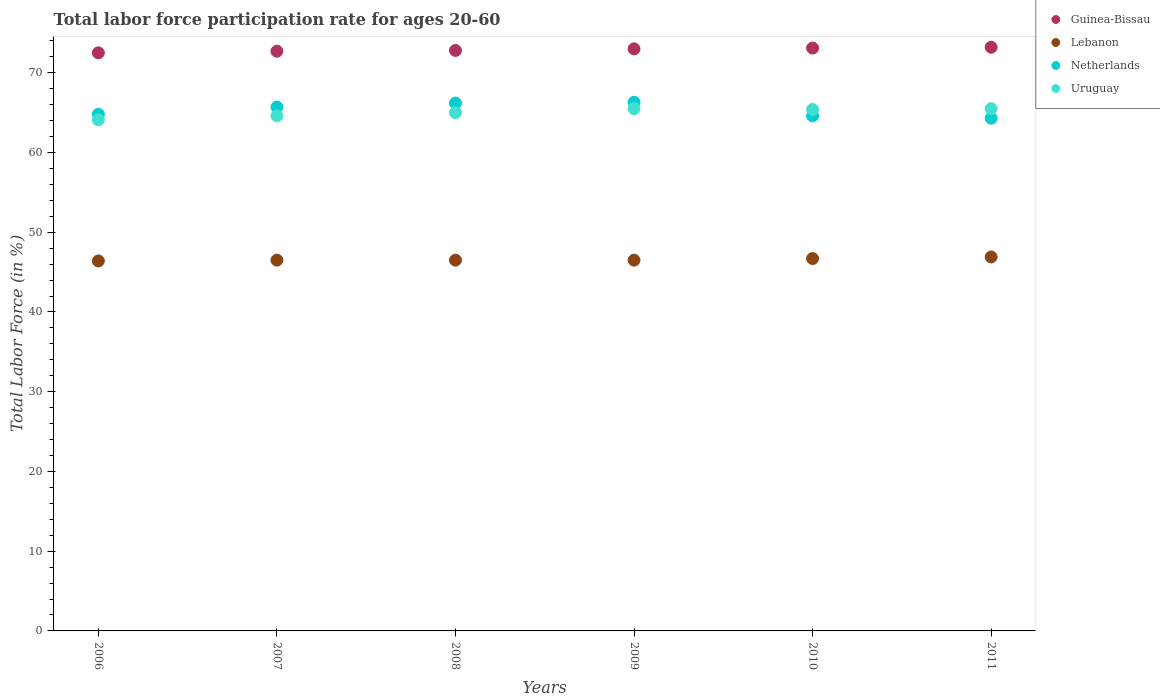How many different coloured dotlines are there?
Offer a terse response. 4. Is the number of dotlines equal to the number of legend labels?
Your answer should be very brief. Yes. What is the labor force participation rate in Lebanon in 2008?
Provide a short and direct response. 46.5. Across all years, what is the maximum labor force participation rate in Lebanon?
Keep it short and to the point. 46.9. Across all years, what is the minimum labor force participation rate in Lebanon?
Give a very brief answer. 46.4. What is the total labor force participation rate in Guinea-Bissau in the graph?
Provide a short and direct response. 437.3. What is the difference between the labor force participation rate in Netherlands in 2007 and that in 2010?
Your answer should be compact. 1.1. What is the difference between the labor force participation rate in Uruguay in 2006 and the labor force participation rate in Lebanon in 2007?
Make the answer very short. 17.6. What is the average labor force participation rate in Uruguay per year?
Your answer should be very brief. 65.02. In the year 2007, what is the difference between the labor force participation rate in Netherlands and labor force participation rate in Uruguay?
Give a very brief answer. 1.1. What is the ratio of the labor force participation rate in Lebanon in 2006 to that in 2007?
Give a very brief answer. 1. What is the difference between the highest and the second highest labor force participation rate in Netherlands?
Keep it short and to the point. 0.1. In how many years, is the labor force participation rate in Guinea-Bissau greater than the average labor force participation rate in Guinea-Bissau taken over all years?
Give a very brief answer. 3. Is the sum of the labor force participation rate in Guinea-Bissau in 2008 and 2010 greater than the maximum labor force participation rate in Lebanon across all years?
Provide a short and direct response. Yes. Is it the case that in every year, the sum of the labor force participation rate in Guinea-Bissau and labor force participation rate in Netherlands  is greater than the sum of labor force participation rate in Lebanon and labor force participation rate in Uruguay?
Keep it short and to the point. Yes. Does the labor force participation rate in Uruguay monotonically increase over the years?
Your response must be concise. No. Is the labor force participation rate in Lebanon strictly greater than the labor force participation rate in Netherlands over the years?
Your answer should be compact. No. How many dotlines are there?
Your answer should be very brief. 4. How many years are there in the graph?
Provide a short and direct response. 6. What is the difference between two consecutive major ticks on the Y-axis?
Offer a terse response. 10. Are the values on the major ticks of Y-axis written in scientific E-notation?
Your answer should be very brief. No. Does the graph contain any zero values?
Give a very brief answer. No. Does the graph contain grids?
Your answer should be compact. No. How many legend labels are there?
Keep it short and to the point. 4. What is the title of the graph?
Your answer should be compact. Total labor force participation rate for ages 20-60. What is the label or title of the Y-axis?
Your answer should be very brief. Total Labor Force (in %). What is the Total Labor Force (in %) of Guinea-Bissau in 2006?
Make the answer very short. 72.5. What is the Total Labor Force (in %) of Lebanon in 2006?
Make the answer very short. 46.4. What is the Total Labor Force (in %) in Netherlands in 2006?
Your response must be concise. 64.8. What is the Total Labor Force (in %) in Uruguay in 2006?
Offer a terse response. 64.1. What is the Total Labor Force (in %) in Guinea-Bissau in 2007?
Your answer should be compact. 72.7. What is the Total Labor Force (in %) in Lebanon in 2007?
Your response must be concise. 46.5. What is the Total Labor Force (in %) of Netherlands in 2007?
Provide a short and direct response. 65.7. What is the Total Labor Force (in %) in Uruguay in 2007?
Make the answer very short. 64.6. What is the Total Labor Force (in %) of Guinea-Bissau in 2008?
Provide a short and direct response. 72.8. What is the Total Labor Force (in %) of Lebanon in 2008?
Ensure brevity in your answer.  46.5. What is the Total Labor Force (in %) in Netherlands in 2008?
Your answer should be compact. 66.2. What is the Total Labor Force (in %) of Uruguay in 2008?
Provide a succinct answer. 65. What is the Total Labor Force (in %) in Guinea-Bissau in 2009?
Your response must be concise. 73. What is the Total Labor Force (in %) of Lebanon in 2009?
Provide a short and direct response. 46.5. What is the Total Labor Force (in %) in Netherlands in 2009?
Give a very brief answer. 66.3. What is the Total Labor Force (in %) of Uruguay in 2009?
Make the answer very short. 65.5. What is the Total Labor Force (in %) in Guinea-Bissau in 2010?
Your response must be concise. 73.1. What is the Total Labor Force (in %) in Lebanon in 2010?
Ensure brevity in your answer.  46.7. What is the Total Labor Force (in %) of Netherlands in 2010?
Your answer should be compact. 64.6. What is the Total Labor Force (in %) in Uruguay in 2010?
Ensure brevity in your answer.  65.4. What is the Total Labor Force (in %) in Guinea-Bissau in 2011?
Give a very brief answer. 73.2. What is the Total Labor Force (in %) of Lebanon in 2011?
Give a very brief answer. 46.9. What is the Total Labor Force (in %) of Netherlands in 2011?
Your response must be concise. 64.3. What is the Total Labor Force (in %) of Uruguay in 2011?
Offer a very short reply. 65.5. Across all years, what is the maximum Total Labor Force (in %) in Guinea-Bissau?
Provide a short and direct response. 73.2. Across all years, what is the maximum Total Labor Force (in %) in Lebanon?
Ensure brevity in your answer.  46.9. Across all years, what is the maximum Total Labor Force (in %) of Netherlands?
Offer a terse response. 66.3. Across all years, what is the maximum Total Labor Force (in %) of Uruguay?
Provide a short and direct response. 65.5. Across all years, what is the minimum Total Labor Force (in %) in Guinea-Bissau?
Provide a succinct answer. 72.5. Across all years, what is the minimum Total Labor Force (in %) in Lebanon?
Your response must be concise. 46.4. Across all years, what is the minimum Total Labor Force (in %) in Netherlands?
Offer a terse response. 64.3. Across all years, what is the minimum Total Labor Force (in %) in Uruguay?
Provide a short and direct response. 64.1. What is the total Total Labor Force (in %) of Guinea-Bissau in the graph?
Offer a terse response. 437.3. What is the total Total Labor Force (in %) of Lebanon in the graph?
Give a very brief answer. 279.5. What is the total Total Labor Force (in %) in Netherlands in the graph?
Keep it short and to the point. 391.9. What is the total Total Labor Force (in %) of Uruguay in the graph?
Offer a very short reply. 390.1. What is the difference between the Total Labor Force (in %) in Guinea-Bissau in 2006 and that in 2007?
Offer a very short reply. -0.2. What is the difference between the Total Labor Force (in %) in Guinea-Bissau in 2006 and that in 2008?
Make the answer very short. -0.3. What is the difference between the Total Labor Force (in %) of Netherlands in 2006 and that in 2008?
Make the answer very short. -1.4. What is the difference between the Total Labor Force (in %) of Netherlands in 2006 and that in 2009?
Make the answer very short. -1.5. What is the difference between the Total Labor Force (in %) of Guinea-Bissau in 2006 and that in 2010?
Offer a terse response. -0.6. What is the difference between the Total Labor Force (in %) in Netherlands in 2006 and that in 2010?
Make the answer very short. 0.2. What is the difference between the Total Labor Force (in %) in Uruguay in 2006 and that in 2010?
Your answer should be compact. -1.3. What is the difference between the Total Labor Force (in %) of Guinea-Bissau in 2006 and that in 2011?
Make the answer very short. -0.7. What is the difference between the Total Labor Force (in %) in Guinea-Bissau in 2007 and that in 2008?
Your response must be concise. -0.1. What is the difference between the Total Labor Force (in %) in Netherlands in 2007 and that in 2008?
Give a very brief answer. -0.5. What is the difference between the Total Labor Force (in %) in Uruguay in 2007 and that in 2008?
Your answer should be very brief. -0.4. What is the difference between the Total Labor Force (in %) in Guinea-Bissau in 2007 and that in 2009?
Offer a very short reply. -0.3. What is the difference between the Total Labor Force (in %) of Netherlands in 2007 and that in 2009?
Offer a terse response. -0.6. What is the difference between the Total Labor Force (in %) of Uruguay in 2007 and that in 2009?
Provide a short and direct response. -0.9. What is the difference between the Total Labor Force (in %) of Guinea-Bissau in 2007 and that in 2010?
Give a very brief answer. -0.4. What is the difference between the Total Labor Force (in %) of Uruguay in 2007 and that in 2010?
Give a very brief answer. -0.8. What is the difference between the Total Labor Force (in %) of Guinea-Bissau in 2007 and that in 2011?
Offer a very short reply. -0.5. What is the difference between the Total Labor Force (in %) of Lebanon in 2007 and that in 2011?
Provide a succinct answer. -0.4. What is the difference between the Total Labor Force (in %) of Netherlands in 2007 and that in 2011?
Give a very brief answer. 1.4. What is the difference between the Total Labor Force (in %) in Lebanon in 2008 and that in 2009?
Your answer should be very brief. 0. What is the difference between the Total Labor Force (in %) in Guinea-Bissau in 2008 and that in 2010?
Keep it short and to the point. -0.3. What is the difference between the Total Labor Force (in %) of Uruguay in 2008 and that in 2010?
Offer a very short reply. -0.4. What is the difference between the Total Labor Force (in %) in Lebanon in 2008 and that in 2011?
Keep it short and to the point. -0.4. What is the difference between the Total Labor Force (in %) of Netherlands in 2008 and that in 2011?
Offer a terse response. 1.9. What is the difference between the Total Labor Force (in %) of Guinea-Bissau in 2009 and that in 2010?
Give a very brief answer. -0.1. What is the difference between the Total Labor Force (in %) of Netherlands in 2009 and that in 2010?
Ensure brevity in your answer.  1.7. What is the difference between the Total Labor Force (in %) of Guinea-Bissau in 2010 and that in 2011?
Your answer should be compact. -0.1. What is the difference between the Total Labor Force (in %) of Lebanon in 2010 and that in 2011?
Your response must be concise. -0.2. What is the difference between the Total Labor Force (in %) of Guinea-Bissau in 2006 and the Total Labor Force (in %) of Lebanon in 2007?
Your answer should be compact. 26. What is the difference between the Total Labor Force (in %) of Guinea-Bissau in 2006 and the Total Labor Force (in %) of Uruguay in 2007?
Give a very brief answer. 7.9. What is the difference between the Total Labor Force (in %) in Lebanon in 2006 and the Total Labor Force (in %) in Netherlands in 2007?
Ensure brevity in your answer.  -19.3. What is the difference between the Total Labor Force (in %) in Lebanon in 2006 and the Total Labor Force (in %) in Uruguay in 2007?
Your response must be concise. -18.2. What is the difference between the Total Labor Force (in %) of Lebanon in 2006 and the Total Labor Force (in %) of Netherlands in 2008?
Your answer should be compact. -19.8. What is the difference between the Total Labor Force (in %) of Lebanon in 2006 and the Total Labor Force (in %) of Uruguay in 2008?
Your response must be concise. -18.6. What is the difference between the Total Labor Force (in %) in Netherlands in 2006 and the Total Labor Force (in %) in Uruguay in 2008?
Your answer should be compact. -0.2. What is the difference between the Total Labor Force (in %) of Guinea-Bissau in 2006 and the Total Labor Force (in %) of Netherlands in 2009?
Keep it short and to the point. 6.2. What is the difference between the Total Labor Force (in %) of Lebanon in 2006 and the Total Labor Force (in %) of Netherlands in 2009?
Your response must be concise. -19.9. What is the difference between the Total Labor Force (in %) in Lebanon in 2006 and the Total Labor Force (in %) in Uruguay in 2009?
Ensure brevity in your answer.  -19.1. What is the difference between the Total Labor Force (in %) of Netherlands in 2006 and the Total Labor Force (in %) of Uruguay in 2009?
Provide a succinct answer. -0.7. What is the difference between the Total Labor Force (in %) in Guinea-Bissau in 2006 and the Total Labor Force (in %) in Lebanon in 2010?
Give a very brief answer. 25.8. What is the difference between the Total Labor Force (in %) of Guinea-Bissau in 2006 and the Total Labor Force (in %) of Uruguay in 2010?
Ensure brevity in your answer.  7.1. What is the difference between the Total Labor Force (in %) of Lebanon in 2006 and the Total Labor Force (in %) of Netherlands in 2010?
Ensure brevity in your answer.  -18.2. What is the difference between the Total Labor Force (in %) of Lebanon in 2006 and the Total Labor Force (in %) of Uruguay in 2010?
Make the answer very short. -19. What is the difference between the Total Labor Force (in %) of Netherlands in 2006 and the Total Labor Force (in %) of Uruguay in 2010?
Your answer should be compact. -0.6. What is the difference between the Total Labor Force (in %) in Guinea-Bissau in 2006 and the Total Labor Force (in %) in Lebanon in 2011?
Provide a succinct answer. 25.6. What is the difference between the Total Labor Force (in %) of Guinea-Bissau in 2006 and the Total Labor Force (in %) of Netherlands in 2011?
Give a very brief answer. 8.2. What is the difference between the Total Labor Force (in %) of Guinea-Bissau in 2006 and the Total Labor Force (in %) of Uruguay in 2011?
Provide a short and direct response. 7. What is the difference between the Total Labor Force (in %) of Lebanon in 2006 and the Total Labor Force (in %) of Netherlands in 2011?
Your response must be concise. -17.9. What is the difference between the Total Labor Force (in %) in Lebanon in 2006 and the Total Labor Force (in %) in Uruguay in 2011?
Your answer should be very brief. -19.1. What is the difference between the Total Labor Force (in %) in Guinea-Bissau in 2007 and the Total Labor Force (in %) in Lebanon in 2008?
Offer a terse response. 26.2. What is the difference between the Total Labor Force (in %) in Lebanon in 2007 and the Total Labor Force (in %) in Netherlands in 2008?
Give a very brief answer. -19.7. What is the difference between the Total Labor Force (in %) in Lebanon in 2007 and the Total Labor Force (in %) in Uruguay in 2008?
Your answer should be very brief. -18.5. What is the difference between the Total Labor Force (in %) of Guinea-Bissau in 2007 and the Total Labor Force (in %) of Lebanon in 2009?
Keep it short and to the point. 26.2. What is the difference between the Total Labor Force (in %) in Guinea-Bissau in 2007 and the Total Labor Force (in %) in Netherlands in 2009?
Your answer should be very brief. 6.4. What is the difference between the Total Labor Force (in %) in Lebanon in 2007 and the Total Labor Force (in %) in Netherlands in 2009?
Ensure brevity in your answer.  -19.8. What is the difference between the Total Labor Force (in %) of Lebanon in 2007 and the Total Labor Force (in %) of Uruguay in 2009?
Make the answer very short. -19. What is the difference between the Total Labor Force (in %) in Guinea-Bissau in 2007 and the Total Labor Force (in %) in Lebanon in 2010?
Provide a succinct answer. 26. What is the difference between the Total Labor Force (in %) of Guinea-Bissau in 2007 and the Total Labor Force (in %) of Netherlands in 2010?
Give a very brief answer. 8.1. What is the difference between the Total Labor Force (in %) of Guinea-Bissau in 2007 and the Total Labor Force (in %) of Uruguay in 2010?
Give a very brief answer. 7.3. What is the difference between the Total Labor Force (in %) of Lebanon in 2007 and the Total Labor Force (in %) of Netherlands in 2010?
Make the answer very short. -18.1. What is the difference between the Total Labor Force (in %) in Lebanon in 2007 and the Total Labor Force (in %) in Uruguay in 2010?
Provide a short and direct response. -18.9. What is the difference between the Total Labor Force (in %) of Netherlands in 2007 and the Total Labor Force (in %) of Uruguay in 2010?
Provide a succinct answer. 0.3. What is the difference between the Total Labor Force (in %) of Guinea-Bissau in 2007 and the Total Labor Force (in %) of Lebanon in 2011?
Keep it short and to the point. 25.8. What is the difference between the Total Labor Force (in %) in Guinea-Bissau in 2007 and the Total Labor Force (in %) in Uruguay in 2011?
Ensure brevity in your answer.  7.2. What is the difference between the Total Labor Force (in %) of Lebanon in 2007 and the Total Labor Force (in %) of Netherlands in 2011?
Your answer should be very brief. -17.8. What is the difference between the Total Labor Force (in %) of Netherlands in 2007 and the Total Labor Force (in %) of Uruguay in 2011?
Provide a short and direct response. 0.2. What is the difference between the Total Labor Force (in %) of Guinea-Bissau in 2008 and the Total Labor Force (in %) of Lebanon in 2009?
Give a very brief answer. 26.3. What is the difference between the Total Labor Force (in %) of Guinea-Bissau in 2008 and the Total Labor Force (in %) of Netherlands in 2009?
Offer a terse response. 6.5. What is the difference between the Total Labor Force (in %) of Lebanon in 2008 and the Total Labor Force (in %) of Netherlands in 2009?
Ensure brevity in your answer.  -19.8. What is the difference between the Total Labor Force (in %) in Lebanon in 2008 and the Total Labor Force (in %) in Uruguay in 2009?
Your answer should be very brief. -19. What is the difference between the Total Labor Force (in %) of Guinea-Bissau in 2008 and the Total Labor Force (in %) of Lebanon in 2010?
Make the answer very short. 26.1. What is the difference between the Total Labor Force (in %) in Guinea-Bissau in 2008 and the Total Labor Force (in %) in Uruguay in 2010?
Offer a very short reply. 7.4. What is the difference between the Total Labor Force (in %) of Lebanon in 2008 and the Total Labor Force (in %) of Netherlands in 2010?
Make the answer very short. -18.1. What is the difference between the Total Labor Force (in %) of Lebanon in 2008 and the Total Labor Force (in %) of Uruguay in 2010?
Your answer should be compact. -18.9. What is the difference between the Total Labor Force (in %) in Guinea-Bissau in 2008 and the Total Labor Force (in %) in Lebanon in 2011?
Your response must be concise. 25.9. What is the difference between the Total Labor Force (in %) of Lebanon in 2008 and the Total Labor Force (in %) of Netherlands in 2011?
Your response must be concise. -17.8. What is the difference between the Total Labor Force (in %) of Lebanon in 2008 and the Total Labor Force (in %) of Uruguay in 2011?
Your answer should be very brief. -19. What is the difference between the Total Labor Force (in %) in Guinea-Bissau in 2009 and the Total Labor Force (in %) in Lebanon in 2010?
Your answer should be compact. 26.3. What is the difference between the Total Labor Force (in %) in Guinea-Bissau in 2009 and the Total Labor Force (in %) in Uruguay in 2010?
Your answer should be very brief. 7.6. What is the difference between the Total Labor Force (in %) in Lebanon in 2009 and the Total Labor Force (in %) in Netherlands in 2010?
Offer a terse response. -18.1. What is the difference between the Total Labor Force (in %) in Lebanon in 2009 and the Total Labor Force (in %) in Uruguay in 2010?
Provide a succinct answer. -18.9. What is the difference between the Total Labor Force (in %) in Guinea-Bissau in 2009 and the Total Labor Force (in %) in Lebanon in 2011?
Keep it short and to the point. 26.1. What is the difference between the Total Labor Force (in %) of Guinea-Bissau in 2009 and the Total Labor Force (in %) of Uruguay in 2011?
Provide a succinct answer. 7.5. What is the difference between the Total Labor Force (in %) in Lebanon in 2009 and the Total Labor Force (in %) in Netherlands in 2011?
Provide a succinct answer. -17.8. What is the difference between the Total Labor Force (in %) of Guinea-Bissau in 2010 and the Total Labor Force (in %) of Lebanon in 2011?
Keep it short and to the point. 26.2. What is the difference between the Total Labor Force (in %) in Guinea-Bissau in 2010 and the Total Labor Force (in %) in Netherlands in 2011?
Your answer should be very brief. 8.8. What is the difference between the Total Labor Force (in %) in Guinea-Bissau in 2010 and the Total Labor Force (in %) in Uruguay in 2011?
Offer a terse response. 7.6. What is the difference between the Total Labor Force (in %) of Lebanon in 2010 and the Total Labor Force (in %) of Netherlands in 2011?
Give a very brief answer. -17.6. What is the difference between the Total Labor Force (in %) in Lebanon in 2010 and the Total Labor Force (in %) in Uruguay in 2011?
Offer a very short reply. -18.8. What is the difference between the Total Labor Force (in %) in Netherlands in 2010 and the Total Labor Force (in %) in Uruguay in 2011?
Provide a succinct answer. -0.9. What is the average Total Labor Force (in %) of Guinea-Bissau per year?
Keep it short and to the point. 72.88. What is the average Total Labor Force (in %) in Lebanon per year?
Offer a terse response. 46.58. What is the average Total Labor Force (in %) of Netherlands per year?
Make the answer very short. 65.32. What is the average Total Labor Force (in %) of Uruguay per year?
Provide a succinct answer. 65.02. In the year 2006, what is the difference between the Total Labor Force (in %) of Guinea-Bissau and Total Labor Force (in %) of Lebanon?
Your answer should be very brief. 26.1. In the year 2006, what is the difference between the Total Labor Force (in %) in Guinea-Bissau and Total Labor Force (in %) in Uruguay?
Make the answer very short. 8.4. In the year 2006, what is the difference between the Total Labor Force (in %) of Lebanon and Total Labor Force (in %) of Netherlands?
Provide a succinct answer. -18.4. In the year 2006, what is the difference between the Total Labor Force (in %) in Lebanon and Total Labor Force (in %) in Uruguay?
Your answer should be very brief. -17.7. In the year 2007, what is the difference between the Total Labor Force (in %) in Guinea-Bissau and Total Labor Force (in %) in Lebanon?
Give a very brief answer. 26.2. In the year 2007, what is the difference between the Total Labor Force (in %) of Guinea-Bissau and Total Labor Force (in %) of Uruguay?
Provide a short and direct response. 8.1. In the year 2007, what is the difference between the Total Labor Force (in %) in Lebanon and Total Labor Force (in %) in Netherlands?
Your answer should be very brief. -19.2. In the year 2007, what is the difference between the Total Labor Force (in %) in Lebanon and Total Labor Force (in %) in Uruguay?
Provide a succinct answer. -18.1. In the year 2008, what is the difference between the Total Labor Force (in %) of Guinea-Bissau and Total Labor Force (in %) of Lebanon?
Give a very brief answer. 26.3. In the year 2008, what is the difference between the Total Labor Force (in %) of Guinea-Bissau and Total Labor Force (in %) of Uruguay?
Offer a very short reply. 7.8. In the year 2008, what is the difference between the Total Labor Force (in %) in Lebanon and Total Labor Force (in %) in Netherlands?
Your response must be concise. -19.7. In the year 2008, what is the difference between the Total Labor Force (in %) in Lebanon and Total Labor Force (in %) in Uruguay?
Provide a succinct answer. -18.5. In the year 2009, what is the difference between the Total Labor Force (in %) of Guinea-Bissau and Total Labor Force (in %) of Lebanon?
Your response must be concise. 26.5. In the year 2009, what is the difference between the Total Labor Force (in %) in Guinea-Bissau and Total Labor Force (in %) in Netherlands?
Your response must be concise. 6.7. In the year 2009, what is the difference between the Total Labor Force (in %) of Lebanon and Total Labor Force (in %) of Netherlands?
Your response must be concise. -19.8. In the year 2009, what is the difference between the Total Labor Force (in %) in Lebanon and Total Labor Force (in %) in Uruguay?
Ensure brevity in your answer.  -19. In the year 2010, what is the difference between the Total Labor Force (in %) in Guinea-Bissau and Total Labor Force (in %) in Lebanon?
Your response must be concise. 26.4. In the year 2010, what is the difference between the Total Labor Force (in %) in Guinea-Bissau and Total Labor Force (in %) in Netherlands?
Give a very brief answer. 8.5. In the year 2010, what is the difference between the Total Labor Force (in %) of Lebanon and Total Labor Force (in %) of Netherlands?
Give a very brief answer. -17.9. In the year 2010, what is the difference between the Total Labor Force (in %) in Lebanon and Total Labor Force (in %) in Uruguay?
Keep it short and to the point. -18.7. In the year 2011, what is the difference between the Total Labor Force (in %) of Guinea-Bissau and Total Labor Force (in %) of Lebanon?
Ensure brevity in your answer.  26.3. In the year 2011, what is the difference between the Total Labor Force (in %) of Guinea-Bissau and Total Labor Force (in %) of Netherlands?
Keep it short and to the point. 8.9. In the year 2011, what is the difference between the Total Labor Force (in %) in Guinea-Bissau and Total Labor Force (in %) in Uruguay?
Your answer should be compact. 7.7. In the year 2011, what is the difference between the Total Labor Force (in %) in Lebanon and Total Labor Force (in %) in Netherlands?
Give a very brief answer. -17.4. In the year 2011, what is the difference between the Total Labor Force (in %) of Lebanon and Total Labor Force (in %) of Uruguay?
Offer a very short reply. -18.6. In the year 2011, what is the difference between the Total Labor Force (in %) of Netherlands and Total Labor Force (in %) of Uruguay?
Ensure brevity in your answer.  -1.2. What is the ratio of the Total Labor Force (in %) of Netherlands in 2006 to that in 2007?
Offer a terse response. 0.99. What is the ratio of the Total Labor Force (in %) of Guinea-Bissau in 2006 to that in 2008?
Offer a terse response. 1. What is the ratio of the Total Labor Force (in %) in Netherlands in 2006 to that in 2008?
Offer a terse response. 0.98. What is the ratio of the Total Labor Force (in %) of Uruguay in 2006 to that in 2008?
Provide a succinct answer. 0.99. What is the ratio of the Total Labor Force (in %) in Lebanon in 2006 to that in 2009?
Your response must be concise. 1. What is the ratio of the Total Labor Force (in %) in Netherlands in 2006 to that in 2009?
Offer a very short reply. 0.98. What is the ratio of the Total Labor Force (in %) of Uruguay in 2006 to that in 2009?
Provide a short and direct response. 0.98. What is the ratio of the Total Labor Force (in %) of Guinea-Bissau in 2006 to that in 2010?
Your answer should be compact. 0.99. What is the ratio of the Total Labor Force (in %) of Netherlands in 2006 to that in 2010?
Provide a short and direct response. 1. What is the ratio of the Total Labor Force (in %) of Uruguay in 2006 to that in 2010?
Keep it short and to the point. 0.98. What is the ratio of the Total Labor Force (in %) in Guinea-Bissau in 2006 to that in 2011?
Provide a short and direct response. 0.99. What is the ratio of the Total Labor Force (in %) in Lebanon in 2006 to that in 2011?
Offer a very short reply. 0.99. What is the ratio of the Total Labor Force (in %) of Netherlands in 2006 to that in 2011?
Ensure brevity in your answer.  1.01. What is the ratio of the Total Labor Force (in %) in Uruguay in 2006 to that in 2011?
Keep it short and to the point. 0.98. What is the ratio of the Total Labor Force (in %) of Guinea-Bissau in 2007 to that in 2008?
Keep it short and to the point. 1. What is the ratio of the Total Labor Force (in %) in Uruguay in 2007 to that in 2008?
Offer a terse response. 0.99. What is the ratio of the Total Labor Force (in %) of Netherlands in 2007 to that in 2009?
Offer a terse response. 0.99. What is the ratio of the Total Labor Force (in %) of Uruguay in 2007 to that in 2009?
Offer a very short reply. 0.99. What is the ratio of the Total Labor Force (in %) in Netherlands in 2007 to that in 2010?
Provide a succinct answer. 1.02. What is the ratio of the Total Labor Force (in %) of Guinea-Bissau in 2007 to that in 2011?
Your response must be concise. 0.99. What is the ratio of the Total Labor Force (in %) of Netherlands in 2007 to that in 2011?
Ensure brevity in your answer.  1.02. What is the ratio of the Total Labor Force (in %) in Uruguay in 2007 to that in 2011?
Ensure brevity in your answer.  0.99. What is the ratio of the Total Labor Force (in %) of Guinea-Bissau in 2008 to that in 2009?
Offer a very short reply. 1. What is the ratio of the Total Labor Force (in %) in Lebanon in 2008 to that in 2009?
Your answer should be compact. 1. What is the ratio of the Total Labor Force (in %) in Netherlands in 2008 to that in 2009?
Ensure brevity in your answer.  1. What is the ratio of the Total Labor Force (in %) in Netherlands in 2008 to that in 2010?
Give a very brief answer. 1.02. What is the ratio of the Total Labor Force (in %) in Uruguay in 2008 to that in 2010?
Make the answer very short. 0.99. What is the ratio of the Total Labor Force (in %) of Netherlands in 2008 to that in 2011?
Offer a terse response. 1.03. What is the ratio of the Total Labor Force (in %) of Uruguay in 2008 to that in 2011?
Ensure brevity in your answer.  0.99. What is the ratio of the Total Labor Force (in %) in Lebanon in 2009 to that in 2010?
Your answer should be very brief. 1. What is the ratio of the Total Labor Force (in %) in Netherlands in 2009 to that in 2010?
Provide a short and direct response. 1.03. What is the ratio of the Total Labor Force (in %) of Uruguay in 2009 to that in 2010?
Keep it short and to the point. 1. What is the ratio of the Total Labor Force (in %) in Netherlands in 2009 to that in 2011?
Provide a short and direct response. 1.03. What is the ratio of the Total Labor Force (in %) of Uruguay in 2009 to that in 2011?
Give a very brief answer. 1. What is the ratio of the Total Labor Force (in %) in Guinea-Bissau in 2010 to that in 2011?
Offer a very short reply. 1. What is the ratio of the Total Labor Force (in %) in Uruguay in 2010 to that in 2011?
Provide a short and direct response. 1. What is the difference between the highest and the second highest Total Labor Force (in %) of Netherlands?
Give a very brief answer. 0.1. What is the difference between the highest and the lowest Total Labor Force (in %) of Guinea-Bissau?
Offer a very short reply. 0.7. What is the difference between the highest and the lowest Total Labor Force (in %) of Netherlands?
Provide a short and direct response. 2. 